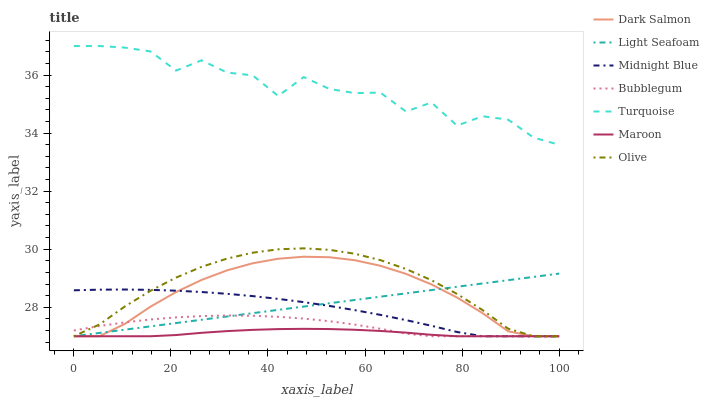Does Midnight Blue have the minimum area under the curve?
Answer yes or no. No. Does Midnight Blue have the maximum area under the curve?
Answer yes or no. No. Is Midnight Blue the smoothest?
Answer yes or no. No. Is Midnight Blue the roughest?
Answer yes or no. No. Does Midnight Blue have the highest value?
Answer yes or no. No. Is Midnight Blue less than Turquoise?
Answer yes or no. Yes. Is Turquoise greater than Olive?
Answer yes or no. Yes. Does Midnight Blue intersect Turquoise?
Answer yes or no. No. 